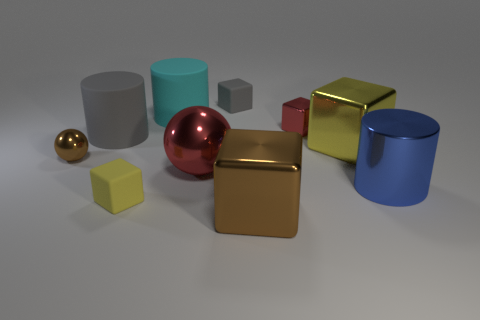What materials do the objects in the image appear to be made of? The objects in the image appear to be rendered with materials that simulate metals and plastics. The reflective surfaces suggest a metallic quality on several items, while the matte finish on others suggests a plastic composition. 